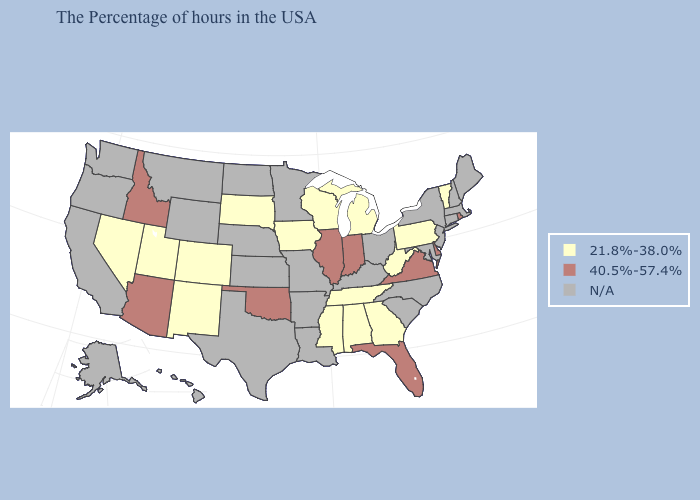Is the legend a continuous bar?
Concise answer only. No. What is the lowest value in the USA?
Quick response, please. 21.8%-38.0%. What is the highest value in states that border New Jersey?
Answer briefly. 40.5%-57.4%. What is the highest value in the USA?
Give a very brief answer. 40.5%-57.4%. Name the states that have a value in the range 21.8%-38.0%?
Concise answer only. Vermont, Pennsylvania, West Virginia, Georgia, Michigan, Alabama, Tennessee, Wisconsin, Mississippi, Iowa, South Dakota, Colorado, New Mexico, Utah, Nevada. What is the value of South Carolina?
Concise answer only. N/A. Does the first symbol in the legend represent the smallest category?
Be succinct. Yes. Does the map have missing data?
Keep it brief. Yes. Does Nevada have the highest value in the West?
Give a very brief answer. No. What is the value of Louisiana?
Give a very brief answer. N/A. Does Rhode Island have the highest value in the Northeast?
Keep it brief. Yes. Does the map have missing data?
Keep it brief. Yes. Name the states that have a value in the range 21.8%-38.0%?
Keep it brief. Vermont, Pennsylvania, West Virginia, Georgia, Michigan, Alabama, Tennessee, Wisconsin, Mississippi, Iowa, South Dakota, Colorado, New Mexico, Utah, Nevada. Does Arizona have the highest value in the West?
Give a very brief answer. Yes. 